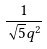<formula> <loc_0><loc_0><loc_500><loc_500>\frac { 1 } { \sqrt { 5 } q ^ { 2 } }</formula> 